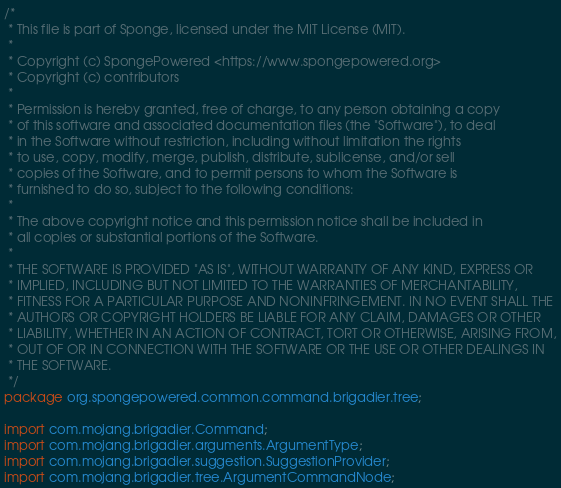<code> <loc_0><loc_0><loc_500><loc_500><_Java_>/*
 * This file is part of Sponge, licensed under the MIT License (MIT).
 *
 * Copyright (c) SpongePowered <https://www.spongepowered.org>
 * Copyright (c) contributors
 *
 * Permission is hereby granted, free of charge, to any person obtaining a copy
 * of this software and associated documentation files (the "Software"), to deal
 * in the Software without restriction, including without limitation the rights
 * to use, copy, modify, merge, publish, distribute, sublicense, and/or sell
 * copies of the Software, and to permit persons to whom the Software is
 * furnished to do so, subject to the following conditions:
 *
 * The above copyright notice and this permission notice shall be included in
 * all copies or substantial portions of the Software.
 *
 * THE SOFTWARE IS PROVIDED "AS IS", WITHOUT WARRANTY OF ANY KIND, EXPRESS OR
 * IMPLIED, INCLUDING BUT NOT LIMITED TO THE WARRANTIES OF MERCHANTABILITY,
 * FITNESS FOR A PARTICULAR PURPOSE AND NONINFRINGEMENT. IN NO EVENT SHALL THE
 * AUTHORS OR COPYRIGHT HOLDERS BE LIABLE FOR ANY CLAIM, DAMAGES OR OTHER
 * LIABILITY, WHETHER IN AN ACTION OF CONTRACT, TORT OR OTHERWISE, ARISING FROM,
 * OUT OF OR IN CONNECTION WITH THE SOFTWARE OR THE USE OR OTHER DEALINGS IN
 * THE SOFTWARE.
 */
package org.spongepowered.common.command.brigadier.tree;

import com.mojang.brigadier.Command;
import com.mojang.brigadier.arguments.ArgumentType;
import com.mojang.brigadier.suggestion.SuggestionProvider;
import com.mojang.brigadier.tree.ArgumentCommandNode;</code> 